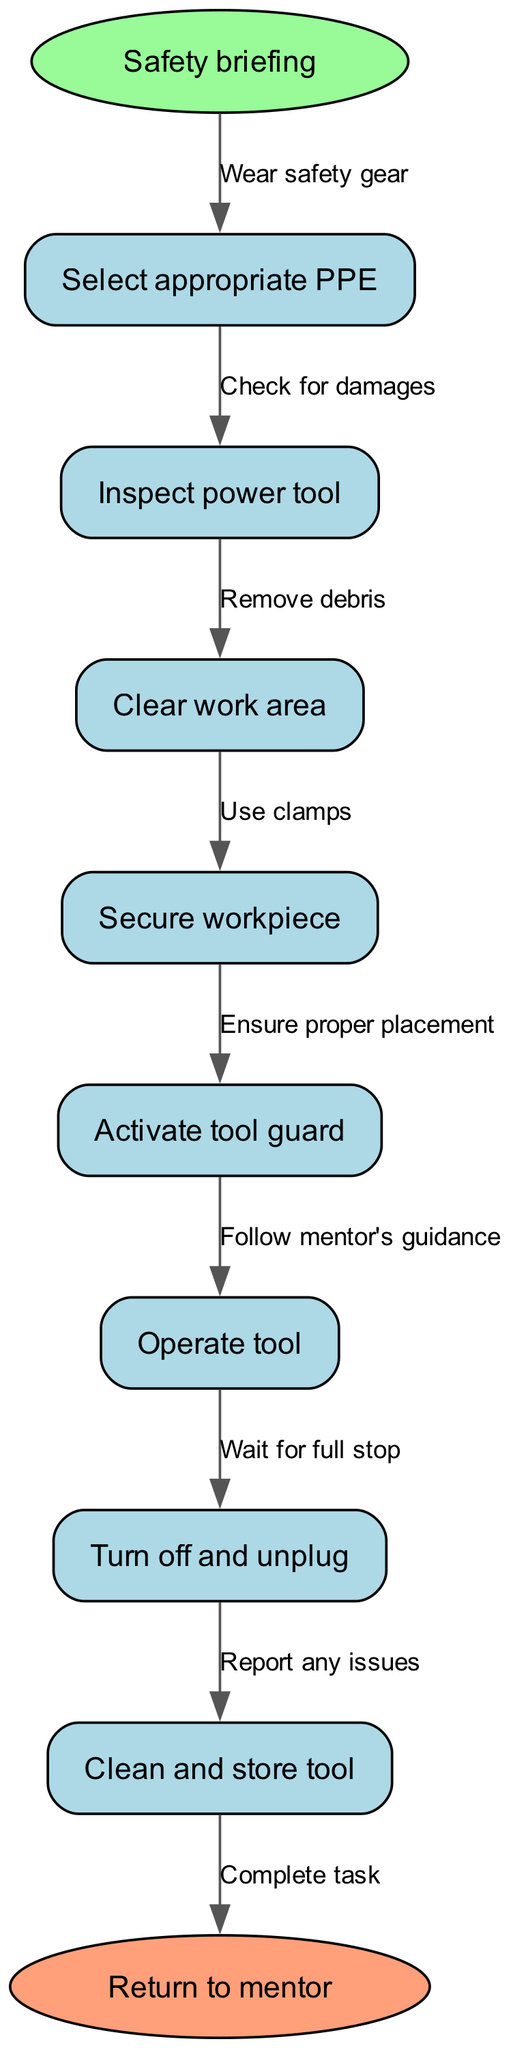What is the starting point of the diagram? The starting point of the diagram is labeled "Safety briefing." It is the first node from which all procedures begin.
Answer: Safety briefing How many nodes are in the flowchart? The flowchart consists of 8 nodes: one start point, seven procedural steps, and one endpoint. The nodes include safety procedures that need to be followed.
Answer: 8 What action follows "Secure workpiece"? The action following "Secure workpiece" is "Activate tool guard." This indicates the necessary step to ensure safety before operating the tool.
Answer: Activate tool guard What is the relationship between "Inspect power tool" and "Clear work area"? The relationship is sequential; "Inspect power tool" comes after "Clear work area." This indicates that the work area must be cleared before inspecting tools.
Answer: Sequential What edge connects "Operate tool" to the next step? The edge connecting "Operate tool" to the next step is "Follow mentor's guidance." This shows the importance of guidance while operating the tool for safety.
Answer: Follow mentor's guidance What should you do after "Turn off and unplug"? After "Turn off and unplug," you should "Clean and store tool." This indicates that proper maintenance follows deactivation.
Answer: Clean and store tool How is the "Return to mentor" node reached after completing the processes? The "Return to mentor" node is reached after finishing all previous steps, indicating completion of tasks and procedures. It also signifies seeking further guidance or confirmation.
Answer: After finishing tasks What precaution should be taken during the "Operate tool" step? The precaution taken during the "Operate tool" step is to "Follow mentor's guidance." This ensures that safety protocols are adhered to during tool operation.
Answer: Follow mentor's guidance 